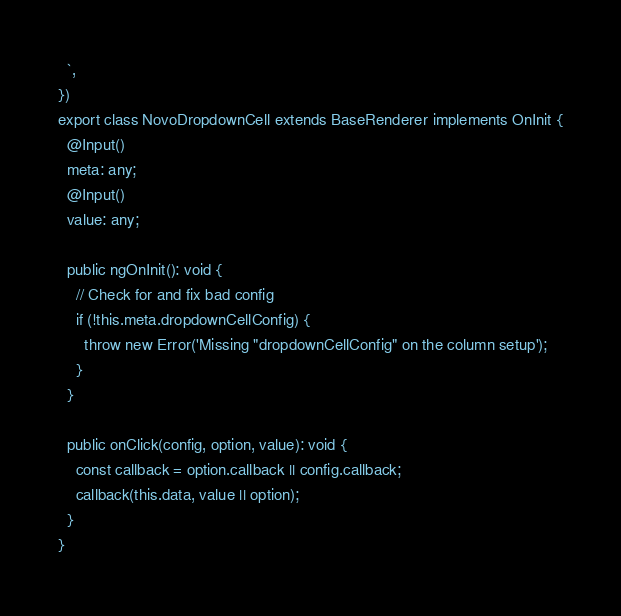Convert code to text. <code><loc_0><loc_0><loc_500><loc_500><_TypeScript_>  `,
})
export class NovoDropdownCell extends BaseRenderer implements OnInit {
  @Input()
  meta: any;
  @Input()
  value: any;

  public ngOnInit(): void {
    // Check for and fix bad config
    if (!this.meta.dropdownCellConfig) {
      throw new Error('Missing "dropdownCellConfig" on the column setup');
    }
  }

  public onClick(config, option, value): void {
    const callback = option.callback || config.callback;
    callback(this.data, value || option);
  }
}
</code> 